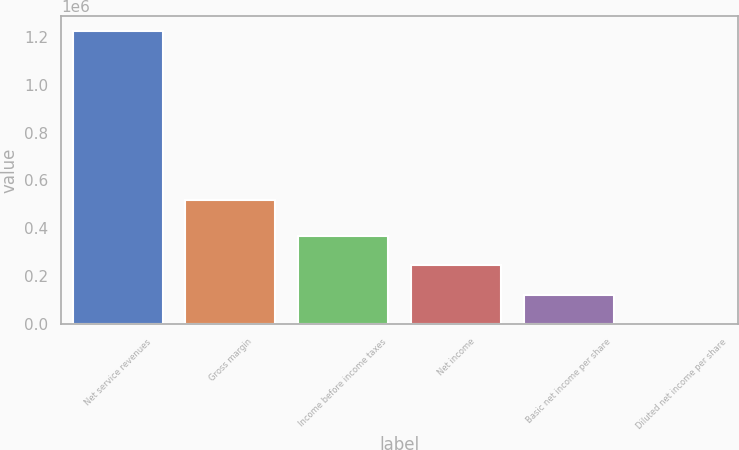Convert chart. <chart><loc_0><loc_0><loc_500><loc_500><bar_chart><fcel>Net service revenues<fcel>Gross margin<fcel>Income before income taxes<fcel>Net income<fcel>Basic net income per share<fcel>Diluted net income per share<nl><fcel>1.22464e+06<fcel>516624<fcel>367393<fcel>244929<fcel>122465<fcel>0.48<nl></chart> 